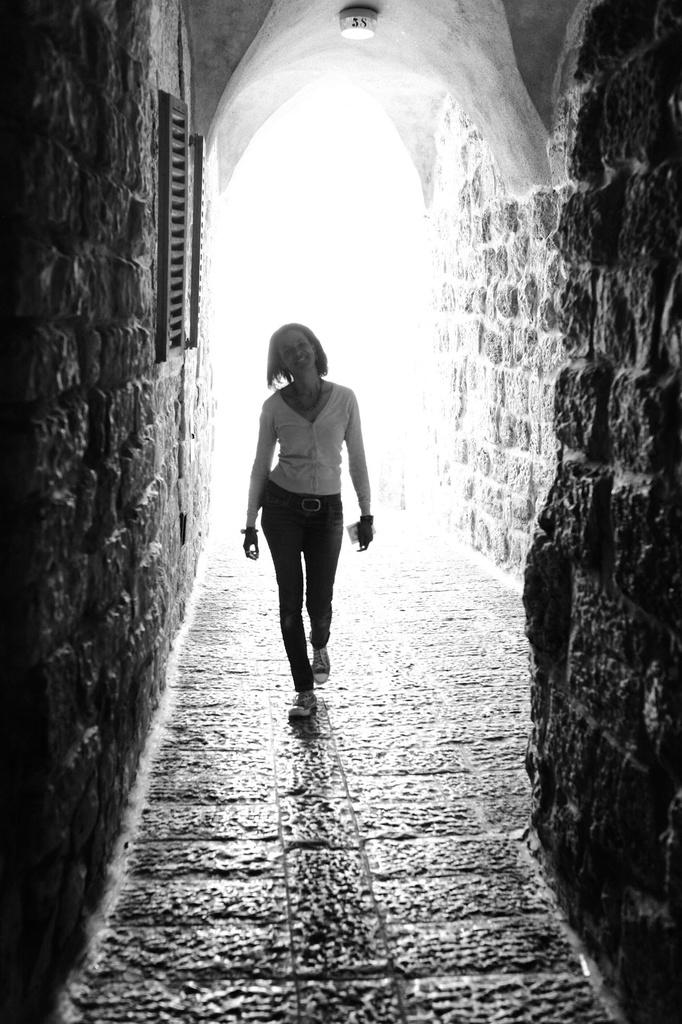Who is the main subject in the image? There is a woman in the image. What is the woman doing in the image? The woman is walking. What can be seen in the background of the image? There is a wall visible in the background of the image. What type of skin condition does the manager have in the image? There is no manager present in the image, and therefore no skin condition can be observed. 